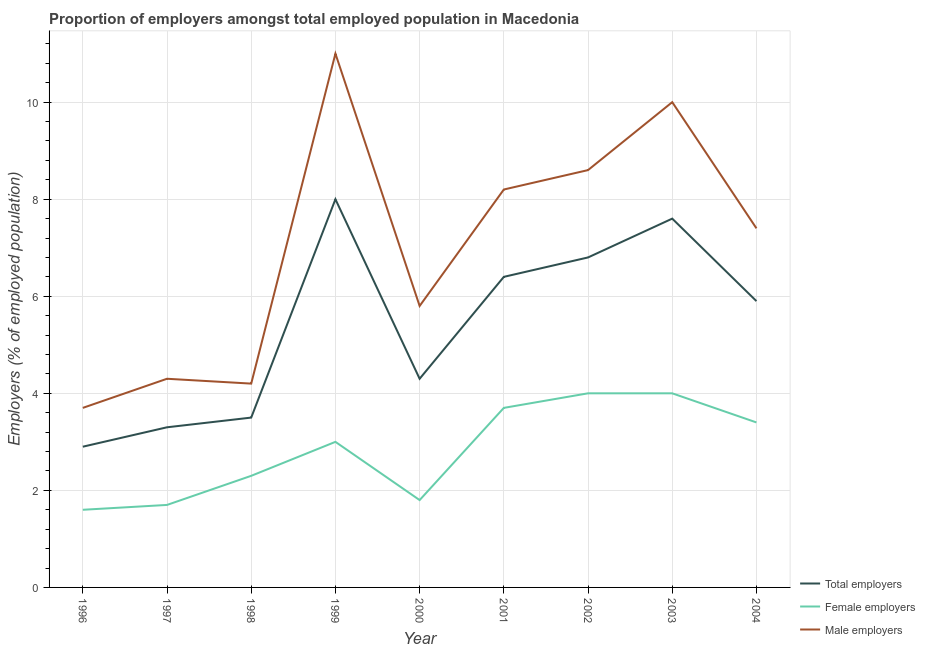What is the percentage of male employers in 2002?
Give a very brief answer. 8.6. Across all years, what is the minimum percentage of male employers?
Provide a short and direct response. 3.7. What is the total percentage of female employers in the graph?
Offer a terse response. 25.5. What is the difference between the percentage of female employers in 1997 and that in 2001?
Make the answer very short. -2. What is the difference between the percentage of female employers in 2002 and the percentage of total employers in 1998?
Keep it short and to the point. 0.5. What is the average percentage of male employers per year?
Keep it short and to the point. 7.02. In the year 1998, what is the difference between the percentage of total employers and percentage of male employers?
Your answer should be compact. -0.7. What is the ratio of the percentage of total employers in 1996 to that in 2002?
Offer a very short reply. 0.43. What is the difference between the highest and the lowest percentage of total employers?
Your response must be concise. 5.1. Is it the case that in every year, the sum of the percentage of total employers and percentage of female employers is greater than the percentage of male employers?
Your answer should be very brief. No. Is the percentage of male employers strictly greater than the percentage of female employers over the years?
Keep it short and to the point. Yes. How many lines are there?
Offer a terse response. 3. How many years are there in the graph?
Make the answer very short. 9. What is the difference between two consecutive major ticks on the Y-axis?
Your answer should be very brief. 2. Does the graph contain grids?
Your answer should be compact. Yes. Where does the legend appear in the graph?
Give a very brief answer. Bottom right. How many legend labels are there?
Ensure brevity in your answer.  3. What is the title of the graph?
Offer a very short reply. Proportion of employers amongst total employed population in Macedonia. Does "Primary education" appear as one of the legend labels in the graph?
Offer a very short reply. No. What is the label or title of the X-axis?
Offer a very short reply. Year. What is the label or title of the Y-axis?
Ensure brevity in your answer.  Employers (% of employed population). What is the Employers (% of employed population) of Total employers in 1996?
Your answer should be very brief. 2.9. What is the Employers (% of employed population) in Female employers in 1996?
Offer a very short reply. 1.6. What is the Employers (% of employed population) of Male employers in 1996?
Offer a very short reply. 3.7. What is the Employers (% of employed population) of Total employers in 1997?
Offer a terse response. 3.3. What is the Employers (% of employed population) of Female employers in 1997?
Your answer should be compact. 1.7. What is the Employers (% of employed population) in Male employers in 1997?
Offer a very short reply. 4.3. What is the Employers (% of employed population) in Total employers in 1998?
Provide a succinct answer. 3.5. What is the Employers (% of employed population) in Female employers in 1998?
Give a very brief answer. 2.3. What is the Employers (% of employed population) of Male employers in 1998?
Offer a very short reply. 4.2. What is the Employers (% of employed population) of Total employers in 1999?
Offer a very short reply. 8. What is the Employers (% of employed population) in Male employers in 1999?
Your answer should be very brief. 11. What is the Employers (% of employed population) of Total employers in 2000?
Your answer should be compact. 4.3. What is the Employers (% of employed population) in Female employers in 2000?
Give a very brief answer. 1.8. What is the Employers (% of employed population) in Male employers in 2000?
Provide a succinct answer. 5.8. What is the Employers (% of employed population) of Total employers in 2001?
Ensure brevity in your answer.  6.4. What is the Employers (% of employed population) of Female employers in 2001?
Make the answer very short. 3.7. What is the Employers (% of employed population) in Male employers in 2001?
Provide a short and direct response. 8.2. What is the Employers (% of employed population) in Total employers in 2002?
Give a very brief answer. 6.8. What is the Employers (% of employed population) of Male employers in 2002?
Offer a very short reply. 8.6. What is the Employers (% of employed population) of Total employers in 2003?
Your response must be concise. 7.6. What is the Employers (% of employed population) in Total employers in 2004?
Your answer should be compact. 5.9. What is the Employers (% of employed population) in Female employers in 2004?
Your answer should be compact. 3.4. What is the Employers (% of employed population) in Male employers in 2004?
Offer a very short reply. 7.4. Across all years, what is the minimum Employers (% of employed population) in Total employers?
Provide a short and direct response. 2.9. Across all years, what is the minimum Employers (% of employed population) of Female employers?
Ensure brevity in your answer.  1.6. Across all years, what is the minimum Employers (% of employed population) in Male employers?
Make the answer very short. 3.7. What is the total Employers (% of employed population) in Total employers in the graph?
Your answer should be compact. 48.7. What is the total Employers (% of employed population) of Female employers in the graph?
Keep it short and to the point. 25.5. What is the total Employers (% of employed population) of Male employers in the graph?
Give a very brief answer. 63.2. What is the difference between the Employers (% of employed population) of Total employers in 1996 and that in 1998?
Your answer should be compact. -0.6. What is the difference between the Employers (% of employed population) of Male employers in 1996 and that in 1998?
Your response must be concise. -0.5. What is the difference between the Employers (% of employed population) in Total employers in 1996 and that in 1999?
Give a very brief answer. -5.1. What is the difference between the Employers (% of employed population) in Total employers in 1996 and that in 2000?
Offer a very short reply. -1.4. What is the difference between the Employers (% of employed population) of Male employers in 1996 and that in 2000?
Make the answer very short. -2.1. What is the difference between the Employers (% of employed population) in Total employers in 1996 and that in 2001?
Provide a succinct answer. -3.5. What is the difference between the Employers (% of employed population) in Male employers in 1996 and that in 2001?
Provide a short and direct response. -4.5. What is the difference between the Employers (% of employed population) in Female employers in 1996 and that in 2002?
Ensure brevity in your answer.  -2.4. What is the difference between the Employers (% of employed population) of Male employers in 1996 and that in 2002?
Offer a terse response. -4.9. What is the difference between the Employers (% of employed population) in Total employers in 1996 and that in 2003?
Keep it short and to the point. -4.7. What is the difference between the Employers (% of employed population) of Male employers in 1996 and that in 2003?
Ensure brevity in your answer.  -6.3. What is the difference between the Employers (% of employed population) in Total employers in 1996 and that in 2004?
Offer a very short reply. -3. What is the difference between the Employers (% of employed population) of Male employers in 1996 and that in 2004?
Make the answer very short. -3.7. What is the difference between the Employers (% of employed population) of Male employers in 1997 and that in 1999?
Offer a terse response. -6.7. What is the difference between the Employers (% of employed population) in Female employers in 1997 and that in 2000?
Your answer should be compact. -0.1. What is the difference between the Employers (% of employed population) in Male employers in 1997 and that in 2000?
Your answer should be compact. -1.5. What is the difference between the Employers (% of employed population) of Total employers in 1997 and that in 2001?
Keep it short and to the point. -3.1. What is the difference between the Employers (% of employed population) of Female employers in 1997 and that in 2001?
Give a very brief answer. -2. What is the difference between the Employers (% of employed population) of Total employers in 1997 and that in 2002?
Ensure brevity in your answer.  -3.5. What is the difference between the Employers (% of employed population) in Female employers in 1997 and that in 2002?
Offer a very short reply. -2.3. What is the difference between the Employers (% of employed population) of Total employers in 1997 and that in 2003?
Your answer should be very brief. -4.3. What is the difference between the Employers (% of employed population) of Male employers in 1997 and that in 2004?
Ensure brevity in your answer.  -3.1. What is the difference between the Employers (% of employed population) in Total employers in 1998 and that in 1999?
Give a very brief answer. -4.5. What is the difference between the Employers (% of employed population) in Female employers in 1998 and that in 1999?
Ensure brevity in your answer.  -0.7. What is the difference between the Employers (% of employed population) of Female employers in 1998 and that in 2000?
Give a very brief answer. 0.5. What is the difference between the Employers (% of employed population) of Male employers in 1998 and that in 2000?
Provide a succinct answer. -1.6. What is the difference between the Employers (% of employed population) in Total employers in 1998 and that in 2001?
Offer a very short reply. -2.9. What is the difference between the Employers (% of employed population) in Female employers in 1998 and that in 2001?
Provide a succinct answer. -1.4. What is the difference between the Employers (% of employed population) in Male employers in 1998 and that in 2001?
Provide a short and direct response. -4. What is the difference between the Employers (% of employed population) of Female employers in 1998 and that in 2002?
Ensure brevity in your answer.  -1.7. What is the difference between the Employers (% of employed population) of Total employers in 1998 and that in 2003?
Offer a terse response. -4.1. What is the difference between the Employers (% of employed population) of Female employers in 1998 and that in 2004?
Provide a succinct answer. -1.1. What is the difference between the Employers (% of employed population) in Total employers in 1999 and that in 2000?
Keep it short and to the point. 3.7. What is the difference between the Employers (% of employed population) of Female employers in 1999 and that in 2000?
Your answer should be very brief. 1.2. What is the difference between the Employers (% of employed population) in Male employers in 1999 and that in 2000?
Your response must be concise. 5.2. What is the difference between the Employers (% of employed population) of Total employers in 1999 and that in 2001?
Offer a terse response. 1.6. What is the difference between the Employers (% of employed population) of Total employers in 1999 and that in 2002?
Your response must be concise. 1.2. What is the difference between the Employers (% of employed population) in Male employers in 1999 and that in 2002?
Your answer should be compact. 2.4. What is the difference between the Employers (% of employed population) in Total employers in 1999 and that in 2003?
Offer a very short reply. 0.4. What is the difference between the Employers (% of employed population) of Female employers in 1999 and that in 2003?
Your answer should be compact. -1. What is the difference between the Employers (% of employed population) in Male employers in 1999 and that in 2003?
Ensure brevity in your answer.  1. What is the difference between the Employers (% of employed population) of Female employers in 1999 and that in 2004?
Your response must be concise. -0.4. What is the difference between the Employers (% of employed population) in Female employers in 2000 and that in 2001?
Your response must be concise. -1.9. What is the difference between the Employers (% of employed population) in Male employers in 2000 and that in 2001?
Make the answer very short. -2.4. What is the difference between the Employers (% of employed population) of Total employers in 2000 and that in 2002?
Make the answer very short. -2.5. What is the difference between the Employers (% of employed population) in Male employers in 2000 and that in 2002?
Give a very brief answer. -2.8. What is the difference between the Employers (% of employed population) in Male employers in 2000 and that in 2003?
Give a very brief answer. -4.2. What is the difference between the Employers (% of employed population) in Total employers in 2000 and that in 2004?
Ensure brevity in your answer.  -1.6. What is the difference between the Employers (% of employed population) in Female employers in 2000 and that in 2004?
Keep it short and to the point. -1.6. What is the difference between the Employers (% of employed population) of Total employers in 2001 and that in 2002?
Keep it short and to the point. -0.4. What is the difference between the Employers (% of employed population) of Total employers in 2001 and that in 2003?
Offer a terse response. -1.2. What is the difference between the Employers (% of employed population) of Female employers in 2001 and that in 2003?
Offer a terse response. -0.3. What is the difference between the Employers (% of employed population) of Total employers in 2001 and that in 2004?
Offer a very short reply. 0.5. What is the difference between the Employers (% of employed population) of Male employers in 2001 and that in 2004?
Provide a short and direct response. 0.8. What is the difference between the Employers (% of employed population) in Total employers in 2002 and that in 2003?
Ensure brevity in your answer.  -0.8. What is the difference between the Employers (% of employed population) of Female employers in 2002 and that in 2003?
Your answer should be compact. 0. What is the difference between the Employers (% of employed population) in Male employers in 2002 and that in 2003?
Offer a terse response. -1.4. What is the difference between the Employers (% of employed population) in Female employers in 1996 and the Employers (% of employed population) in Male employers in 1997?
Give a very brief answer. -2.7. What is the difference between the Employers (% of employed population) of Total employers in 1996 and the Employers (% of employed population) of Female employers in 1998?
Your response must be concise. 0.6. What is the difference between the Employers (% of employed population) of Total employers in 1996 and the Employers (% of employed population) of Male employers in 1998?
Provide a short and direct response. -1.3. What is the difference between the Employers (% of employed population) of Female employers in 1996 and the Employers (% of employed population) of Male employers in 1998?
Make the answer very short. -2.6. What is the difference between the Employers (% of employed population) in Total employers in 1996 and the Employers (% of employed population) in Female employers in 1999?
Ensure brevity in your answer.  -0.1. What is the difference between the Employers (% of employed population) of Total employers in 1996 and the Employers (% of employed population) of Male employers in 1999?
Your answer should be very brief. -8.1. What is the difference between the Employers (% of employed population) of Female employers in 1996 and the Employers (% of employed population) of Male employers in 1999?
Provide a succinct answer. -9.4. What is the difference between the Employers (% of employed population) of Total employers in 1996 and the Employers (% of employed population) of Female employers in 2000?
Your response must be concise. 1.1. What is the difference between the Employers (% of employed population) in Female employers in 1996 and the Employers (% of employed population) in Male employers in 2000?
Ensure brevity in your answer.  -4.2. What is the difference between the Employers (% of employed population) in Total employers in 1996 and the Employers (% of employed population) in Male employers in 2001?
Make the answer very short. -5.3. What is the difference between the Employers (% of employed population) in Total employers in 1996 and the Employers (% of employed population) in Female employers in 2002?
Provide a succinct answer. -1.1. What is the difference between the Employers (% of employed population) in Female employers in 1996 and the Employers (% of employed population) in Male employers in 2002?
Your answer should be compact. -7. What is the difference between the Employers (% of employed population) in Total employers in 1996 and the Employers (% of employed population) in Female employers in 2004?
Ensure brevity in your answer.  -0.5. What is the difference between the Employers (% of employed population) of Female employers in 1996 and the Employers (% of employed population) of Male employers in 2004?
Make the answer very short. -5.8. What is the difference between the Employers (% of employed population) in Total employers in 1997 and the Employers (% of employed population) in Male employers in 1998?
Provide a short and direct response. -0.9. What is the difference between the Employers (% of employed population) in Total employers in 1997 and the Employers (% of employed population) in Female employers in 1999?
Provide a succinct answer. 0.3. What is the difference between the Employers (% of employed population) in Female employers in 1997 and the Employers (% of employed population) in Male employers in 1999?
Ensure brevity in your answer.  -9.3. What is the difference between the Employers (% of employed population) of Total employers in 1997 and the Employers (% of employed population) of Male employers in 2000?
Offer a very short reply. -2.5. What is the difference between the Employers (% of employed population) in Female employers in 1997 and the Employers (% of employed population) in Male employers in 2000?
Your answer should be very brief. -4.1. What is the difference between the Employers (% of employed population) in Total employers in 1997 and the Employers (% of employed population) in Male employers in 2001?
Offer a terse response. -4.9. What is the difference between the Employers (% of employed population) of Female employers in 1997 and the Employers (% of employed population) of Male employers in 2001?
Make the answer very short. -6.5. What is the difference between the Employers (% of employed population) in Total employers in 1997 and the Employers (% of employed population) in Male employers in 2002?
Your response must be concise. -5.3. What is the difference between the Employers (% of employed population) of Female employers in 1997 and the Employers (% of employed population) of Male employers in 2002?
Give a very brief answer. -6.9. What is the difference between the Employers (% of employed population) in Total employers in 1997 and the Employers (% of employed population) in Female employers in 2003?
Your answer should be very brief. -0.7. What is the difference between the Employers (% of employed population) of Total employers in 1997 and the Employers (% of employed population) of Male employers in 2003?
Your answer should be compact. -6.7. What is the difference between the Employers (% of employed population) of Female employers in 1997 and the Employers (% of employed population) of Male employers in 2003?
Keep it short and to the point. -8.3. What is the difference between the Employers (% of employed population) in Total employers in 1997 and the Employers (% of employed population) in Male employers in 2004?
Give a very brief answer. -4.1. What is the difference between the Employers (% of employed population) of Total employers in 1998 and the Employers (% of employed population) of Female employers in 2000?
Your answer should be very brief. 1.7. What is the difference between the Employers (% of employed population) of Female employers in 1998 and the Employers (% of employed population) of Male employers in 2001?
Your response must be concise. -5.9. What is the difference between the Employers (% of employed population) of Total employers in 1998 and the Employers (% of employed population) of Female employers in 2002?
Your answer should be very brief. -0.5. What is the difference between the Employers (% of employed population) in Total employers in 1998 and the Employers (% of employed population) in Male employers in 2002?
Your answer should be very brief. -5.1. What is the difference between the Employers (% of employed population) in Total employers in 1998 and the Employers (% of employed population) in Female employers in 2003?
Provide a succinct answer. -0.5. What is the difference between the Employers (% of employed population) in Total employers in 1998 and the Employers (% of employed population) in Male employers in 2003?
Your answer should be compact. -6.5. What is the difference between the Employers (% of employed population) in Total employers in 1998 and the Employers (% of employed population) in Female employers in 2004?
Keep it short and to the point. 0.1. What is the difference between the Employers (% of employed population) in Total employers in 1998 and the Employers (% of employed population) in Male employers in 2004?
Provide a succinct answer. -3.9. What is the difference between the Employers (% of employed population) of Female employers in 1998 and the Employers (% of employed population) of Male employers in 2004?
Your response must be concise. -5.1. What is the difference between the Employers (% of employed population) of Female employers in 1999 and the Employers (% of employed population) of Male employers in 2000?
Offer a very short reply. -2.8. What is the difference between the Employers (% of employed population) in Total employers in 1999 and the Employers (% of employed population) in Male employers in 2004?
Make the answer very short. 0.6. What is the difference between the Employers (% of employed population) of Total employers in 2000 and the Employers (% of employed population) of Female employers in 2001?
Provide a succinct answer. 0.6. What is the difference between the Employers (% of employed population) in Female employers in 2000 and the Employers (% of employed population) in Male employers in 2002?
Offer a very short reply. -6.8. What is the difference between the Employers (% of employed population) in Total employers in 2000 and the Employers (% of employed population) in Female employers in 2003?
Your response must be concise. 0.3. What is the difference between the Employers (% of employed population) of Total employers in 2000 and the Employers (% of employed population) of Male employers in 2003?
Make the answer very short. -5.7. What is the difference between the Employers (% of employed population) in Female employers in 2000 and the Employers (% of employed population) in Male employers in 2003?
Provide a short and direct response. -8.2. What is the difference between the Employers (% of employed population) in Total employers in 2000 and the Employers (% of employed population) in Female employers in 2004?
Give a very brief answer. 0.9. What is the difference between the Employers (% of employed population) in Female employers in 2000 and the Employers (% of employed population) in Male employers in 2004?
Provide a short and direct response. -5.6. What is the difference between the Employers (% of employed population) in Total employers in 2001 and the Employers (% of employed population) in Female employers in 2002?
Your answer should be very brief. 2.4. What is the difference between the Employers (% of employed population) in Total employers in 2001 and the Employers (% of employed population) in Male employers in 2002?
Offer a terse response. -2.2. What is the difference between the Employers (% of employed population) in Female employers in 2001 and the Employers (% of employed population) in Male employers in 2003?
Your response must be concise. -6.3. What is the difference between the Employers (% of employed population) of Female employers in 2001 and the Employers (% of employed population) of Male employers in 2004?
Offer a very short reply. -3.7. What is the difference between the Employers (% of employed population) in Total employers in 2002 and the Employers (% of employed population) in Male employers in 2003?
Provide a succinct answer. -3.2. What is the difference between the Employers (% of employed population) in Total employers in 2002 and the Employers (% of employed population) in Female employers in 2004?
Make the answer very short. 3.4. What is the difference between the Employers (% of employed population) in Total employers in 2002 and the Employers (% of employed population) in Male employers in 2004?
Your answer should be compact. -0.6. What is the difference between the Employers (% of employed population) of Female employers in 2002 and the Employers (% of employed population) of Male employers in 2004?
Your answer should be compact. -3.4. What is the difference between the Employers (% of employed population) in Total employers in 2003 and the Employers (% of employed population) in Male employers in 2004?
Your response must be concise. 0.2. What is the average Employers (% of employed population) in Total employers per year?
Offer a very short reply. 5.41. What is the average Employers (% of employed population) of Female employers per year?
Offer a terse response. 2.83. What is the average Employers (% of employed population) in Male employers per year?
Provide a short and direct response. 7.02. In the year 1996, what is the difference between the Employers (% of employed population) of Total employers and Employers (% of employed population) of Female employers?
Your answer should be very brief. 1.3. In the year 1996, what is the difference between the Employers (% of employed population) of Female employers and Employers (% of employed population) of Male employers?
Provide a succinct answer. -2.1. In the year 1997, what is the difference between the Employers (% of employed population) of Female employers and Employers (% of employed population) of Male employers?
Make the answer very short. -2.6. In the year 1998, what is the difference between the Employers (% of employed population) in Female employers and Employers (% of employed population) in Male employers?
Provide a succinct answer. -1.9. In the year 2000, what is the difference between the Employers (% of employed population) of Total employers and Employers (% of employed population) of Male employers?
Ensure brevity in your answer.  -1.5. In the year 2001, what is the difference between the Employers (% of employed population) in Total employers and Employers (% of employed population) in Female employers?
Your answer should be compact. 2.7. In the year 2001, what is the difference between the Employers (% of employed population) of Total employers and Employers (% of employed population) of Male employers?
Ensure brevity in your answer.  -1.8. In the year 2001, what is the difference between the Employers (% of employed population) in Female employers and Employers (% of employed population) in Male employers?
Your response must be concise. -4.5. In the year 2002, what is the difference between the Employers (% of employed population) of Female employers and Employers (% of employed population) of Male employers?
Offer a terse response. -4.6. In the year 2003, what is the difference between the Employers (% of employed population) of Total employers and Employers (% of employed population) of Male employers?
Your answer should be compact. -2.4. In the year 2004, what is the difference between the Employers (% of employed population) in Total employers and Employers (% of employed population) in Female employers?
Keep it short and to the point. 2.5. In the year 2004, what is the difference between the Employers (% of employed population) of Total employers and Employers (% of employed population) of Male employers?
Ensure brevity in your answer.  -1.5. What is the ratio of the Employers (% of employed population) of Total employers in 1996 to that in 1997?
Your answer should be compact. 0.88. What is the ratio of the Employers (% of employed population) of Female employers in 1996 to that in 1997?
Your answer should be compact. 0.94. What is the ratio of the Employers (% of employed population) in Male employers in 1996 to that in 1997?
Keep it short and to the point. 0.86. What is the ratio of the Employers (% of employed population) in Total employers in 1996 to that in 1998?
Provide a succinct answer. 0.83. What is the ratio of the Employers (% of employed population) in Female employers in 1996 to that in 1998?
Offer a terse response. 0.7. What is the ratio of the Employers (% of employed population) of Male employers in 1996 to that in 1998?
Your answer should be very brief. 0.88. What is the ratio of the Employers (% of employed population) in Total employers in 1996 to that in 1999?
Provide a succinct answer. 0.36. What is the ratio of the Employers (% of employed population) in Female employers in 1996 to that in 1999?
Keep it short and to the point. 0.53. What is the ratio of the Employers (% of employed population) in Male employers in 1996 to that in 1999?
Keep it short and to the point. 0.34. What is the ratio of the Employers (% of employed population) in Total employers in 1996 to that in 2000?
Make the answer very short. 0.67. What is the ratio of the Employers (% of employed population) in Male employers in 1996 to that in 2000?
Provide a short and direct response. 0.64. What is the ratio of the Employers (% of employed population) in Total employers in 1996 to that in 2001?
Ensure brevity in your answer.  0.45. What is the ratio of the Employers (% of employed population) in Female employers in 1996 to that in 2001?
Give a very brief answer. 0.43. What is the ratio of the Employers (% of employed population) in Male employers in 1996 to that in 2001?
Keep it short and to the point. 0.45. What is the ratio of the Employers (% of employed population) of Total employers in 1996 to that in 2002?
Offer a terse response. 0.43. What is the ratio of the Employers (% of employed population) in Male employers in 1996 to that in 2002?
Offer a very short reply. 0.43. What is the ratio of the Employers (% of employed population) in Total employers in 1996 to that in 2003?
Provide a short and direct response. 0.38. What is the ratio of the Employers (% of employed population) in Female employers in 1996 to that in 2003?
Provide a short and direct response. 0.4. What is the ratio of the Employers (% of employed population) in Male employers in 1996 to that in 2003?
Offer a very short reply. 0.37. What is the ratio of the Employers (% of employed population) of Total employers in 1996 to that in 2004?
Offer a very short reply. 0.49. What is the ratio of the Employers (% of employed population) in Female employers in 1996 to that in 2004?
Your answer should be compact. 0.47. What is the ratio of the Employers (% of employed population) in Total employers in 1997 to that in 1998?
Keep it short and to the point. 0.94. What is the ratio of the Employers (% of employed population) of Female employers in 1997 to that in 1998?
Your answer should be compact. 0.74. What is the ratio of the Employers (% of employed population) in Male employers in 1997 to that in 1998?
Keep it short and to the point. 1.02. What is the ratio of the Employers (% of employed population) in Total employers in 1997 to that in 1999?
Your answer should be very brief. 0.41. What is the ratio of the Employers (% of employed population) in Female employers in 1997 to that in 1999?
Give a very brief answer. 0.57. What is the ratio of the Employers (% of employed population) in Male employers in 1997 to that in 1999?
Ensure brevity in your answer.  0.39. What is the ratio of the Employers (% of employed population) of Total employers in 1997 to that in 2000?
Your response must be concise. 0.77. What is the ratio of the Employers (% of employed population) in Female employers in 1997 to that in 2000?
Make the answer very short. 0.94. What is the ratio of the Employers (% of employed population) of Male employers in 1997 to that in 2000?
Offer a terse response. 0.74. What is the ratio of the Employers (% of employed population) in Total employers in 1997 to that in 2001?
Provide a succinct answer. 0.52. What is the ratio of the Employers (% of employed population) of Female employers in 1997 to that in 2001?
Make the answer very short. 0.46. What is the ratio of the Employers (% of employed population) in Male employers in 1997 to that in 2001?
Keep it short and to the point. 0.52. What is the ratio of the Employers (% of employed population) of Total employers in 1997 to that in 2002?
Ensure brevity in your answer.  0.49. What is the ratio of the Employers (% of employed population) of Female employers in 1997 to that in 2002?
Offer a very short reply. 0.42. What is the ratio of the Employers (% of employed population) in Total employers in 1997 to that in 2003?
Your response must be concise. 0.43. What is the ratio of the Employers (% of employed population) of Female employers in 1997 to that in 2003?
Your response must be concise. 0.42. What is the ratio of the Employers (% of employed population) in Male employers in 1997 to that in 2003?
Make the answer very short. 0.43. What is the ratio of the Employers (% of employed population) of Total employers in 1997 to that in 2004?
Give a very brief answer. 0.56. What is the ratio of the Employers (% of employed population) of Male employers in 1997 to that in 2004?
Provide a short and direct response. 0.58. What is the ratio of the Employers (% of employed population) in Total employers in 1998 to that in 1999?
Your response must be concise. 0.44. What is the ratio of the Employers (% of employed population) in Female employers in 1998 to that in 1999?
Make the answer very short. 0.77. What is the ratio of the Employers (% of employed population) in Male employers in 1998 to that in 1999?
Offer a terse response. 0.38. What is the ratio of the Employers (% of employed population) of Total employers in 1998 to that in 2000?
Your response must be concise. 0.81. What is the ratio of the Employers (% of employed population) of Female employers in 1998 to that in 2000?
Make the answer very short. 1.28. What is the ratio of the Employers (% of employed population) of Male employers in 1998 to that in 2000?
Your response must be concise. 0.72. What is the ratio of the Employers (% of employed population) in Total employers in 1998 to that in 2001?
Your answer should be very brief. 0.55. What is the ratio of the Employers (% of employed population) of Female employers in 1998 to that in 2001?
Provide a short and direct response. 0.62. What is the ratio of the Employers (% of employed population) of Male employers in 1998 to that in 2001?
Ensure brevity in your answer.  0.51. What is the ratio of the Employers (% of employed population) of Total employers in 1998 to that in 2002?
Offer a very short reply. 0.51. What is the ratio of the Employers (% of employed population) in Female employers in 1998 to that in 2002?
Your answer should be compact. 0.57. What is the ratio of the Employers (% of employed population) of Male employers in 1998 to that in 2002?
Offer a terse response. 0.49. What is the ratio of the Employers (% of employed population) in Total employers in 1998 to that in 2003?
Your response must be concise. 0.46. What is the ratio of the Employers (% of employed population) in Female employers in 1998 to that in 2003?
Ensure brevity in your answer.  0.57. What is the ratio of the Employers (% of employed population) in Male employers in 1998 to that in 2003?
Your answer should be very brief. 0.42. What is the ratio of the Employers (% of employed population) of Total employers in 1998 to that in 2004?
Provide a succinct answer. 0.59. What is the ratio of the Employers (% of employed population) in Female employers in 1998 to that in 2004?
Your answer should be compact. 0.68. What is the ratio of the Employers (% of employed population) in Male employers in 1998 to that in 2004?
Give a very brief answer. 0.57. What is the ratio of the Employers (% of employed population) in Total employers in 1999 to that in 2000?
Make the answer very short. 1.86. What is the ratio of the Employers (% of employed population) in Male employers in 1999 to that in 2000?
Make the answer very short. 1.9. What is the ratio of the Employers (% of employed population) in Total employers in 1999 to that in 2001?
Make the answer very short. 1.25. What is the ratio of the Employers (% of employed population) of Female employers in 1999 to that in 2001?
Give a very brief answer. 0.81. What is the ratio of the Employers (% of employed population) of Male employers in 1999 to that in 2001?
Provide a succinct answer. 1.34. What is the ratio of the Employers (% of employed population) in Total employers in 1999 to that in 2002?
Ensure brevity in your answer.  1.18. What is the ratio of the Employers (% of employed population) of Male employers in 1999 to that in 2002?
Your response must be concise. 1.28. What is the ratio of the Employers (% of employed population) of Total employers in 1999 to that in 2003?
Make the answer very short. 1.05. What is the ratio of the Employers (% of employed population) in Female employers in 1999 to that in 2003?
Provide a short and direct response. 0.75. What is the ratio of the Employers (% of employed population) in Male employers in 1999 to that in 2003?
Give a very brief answer. 1.1. What is the ratio of the Employers (% of employed population) in Total employers in 1999 to that in 2004?
Provide a short and direct response. 1.36. What is the ratio of the Employers (% of employed population) of Female employers in 1999 to that in 2004?
Give a very brief answer. 0.88. What is the ratio of the Employers (% of employed population) of Male employers in 1999 to that in 2004?
Offer a very short reply. 1.49. What is the ratio of the Employers (% of employed population) in Total employers in 2000 to that in 2001?
Your answer should be compact. 0.67. What is the ratio of the Employers (% of employed population) of Female employers in 2000 to that in 2001?
Make the answer very short. 0.49. What is the ratio of the Employers (% of employed population) of Male employers in 2000 to that in 2001?
Your response must be concise. 0.71. What is the ratio of the Employers (% of employed population) in Total employers in 2000 to that in 2002?
Provide a succinct answer. 0.63. What is the ratio of the Employers (% of employed population) in Female employers in 2000 to that in 2002?
Your response must be concise. 0.45. What is the ratio of the Employers (% of employed population) of Male employers in 2000 to that in 2002?
Offer a very short reply. 0.67. What is the ratio of the Employers (% of employed population) in Total employers in 2000 to that in 2003?
Make the answer very short. 0.57. What is the ratio of the Employers (% of employed population) of Female employers in 2000 to that in 2003?
Offer a terse response. 0.45. What is the ratio of the Employers (% of employed population) of Male employers in 2000 to that in 2003?
Give a very brief answer. 0.58. What is the ratio of the Employers (% of employed population) of Total employers in 2000 to that in 2004?
Offer a terse response. 0.73. What is the ratio of the Employers (% of employed population) in Female employers in 2000 to that in 2004?
Your answer should be compact. 0.53. What is the ratio of the Employers (% of employed population) of Male employers in 2000 to that in 2004?
Provide a short and direct response. 0.78. What is the ratio of the Employers (% of employed population) of Total employers in 2001 to that in 2002?
Keep it short and to the point. 0.94. What is the ratio of the Employers (% of employed population) in Female employers in 2001 to that in 2002?
Provide a short and direct response. 0.93. What is the ratio of the Employers (% of employed population) of Male employers in 2001 to that in 2002?
Provide a short and direct response. 0.95. What is the ratio of the Employers (% of employed population) of Total employers in 2001 to that in 2003?
Keep it short and to the point. 0.84. What is the ratio of the Employers (% of employed population) of Female employers in 2001 to that in 2003?
Provide a succinct answer. 0.93. What is the ratio of the Employers (% of employed population) in Male employers in 2001 to that in 2003?
Give a very brief answer. 0.82. What is the ratio of the Employers (% of employed population) of Total employers in 2001 to that in 2004?
Offer a very short reply. 1.08. What is the ratio of the Employers (% of employed population) of Female employers in 2001 to that in 2004?
Provide a succinct answer. 1.09. What is the ratio of the Employers (% of employed population) of Male employers in 2001 to that in 2004?
Keep it short and to the point. 1.11. What is the ratio of the Employers (% of employed population) in Total employers in 2002 to that in 2003?
Ensure brevity in your answer.  0.89. What is the ratio of the Employers (% of employed population) in Female employers in 2002 to that in 2003?
Your answer should be compact. 1. What is the ratio of the Employers (% of employed population) in Male employers in 2002 to that in 2003?
Provide a succinct answer. 0.86. What is the ratio of the Employers (% of employed population) of Total employers in 2002 to that in 2004?
Offer a terse response. 1.15. What is the ratio of the Employers (% of employed population) of Female employers in 2002 to that in 2004?
Make the answer very short. 1.18. What is the ratio of the Employers (% of employed population) in Male employers in 2002 to that in 2004?
Provide a short and direct response. 1.16. What is the ratio of the Employers (% of employed population) of Total employers in 2003 to that in 2004?
Your answer should be very brief. 1.29. What is the ratio of the Employers (% of employed population) in Female employers in 2003 to that in 2004?
Give a very brief answer. 1.18. What is the ratio of the Employers (% of employed population) of Male employers in 2003 to that in 2004?
Provide a succinct answer. 1.35. What is the difference between the highest and the second highest Employers (% of employed population) of Total employers?
Ensure brevity in your answer.  0.4. What is the difference between the highest and the second highest Employers (% of employed population) in Male employers?
Keep it short and to the point. 1. What is the difference between the highest and the lowest Employers (% of employed population) of Male employers?
Provide a short and direct response. 7.3. 